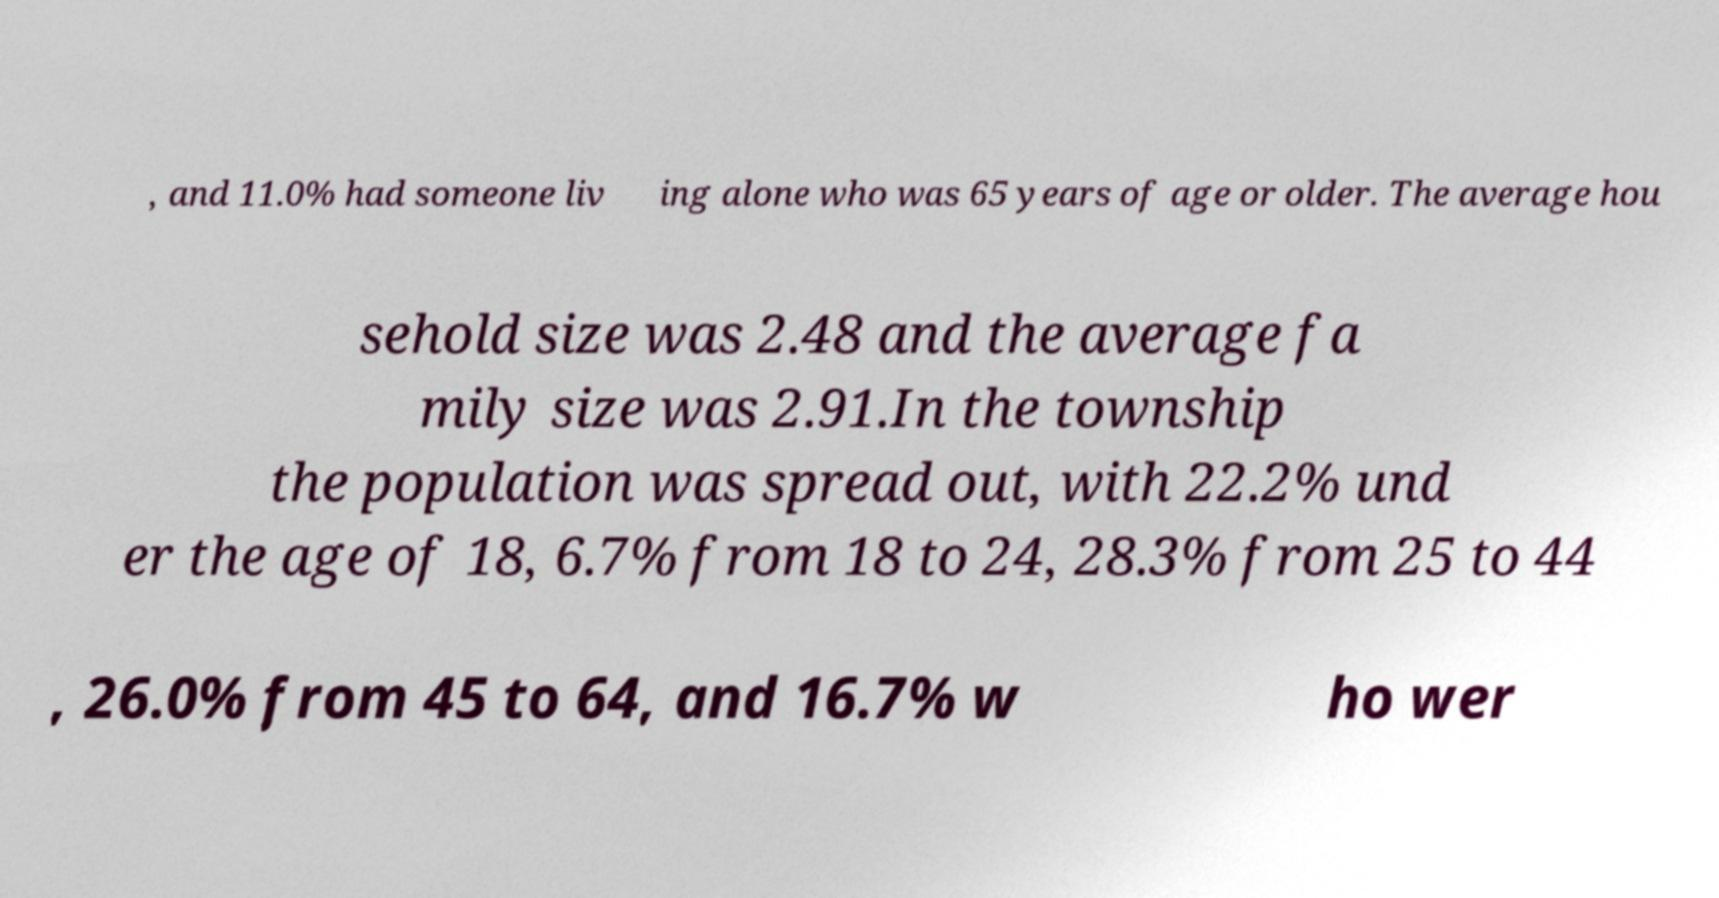For documentation purposes, I need the text within this image transcribed. Could you provide that? , and 11.0% had someone liv ing alone who was 65 years of age or older. The average hou sehold size was 2.48 and the average fa mily size was 2.91.In the township the population was spread out, with 22.2% und er the age of 18, 6.7% from 18 to 24, 28.3% from 25 to 44 , 26.0% from 45 to 64, and 16.7% w ho wer 